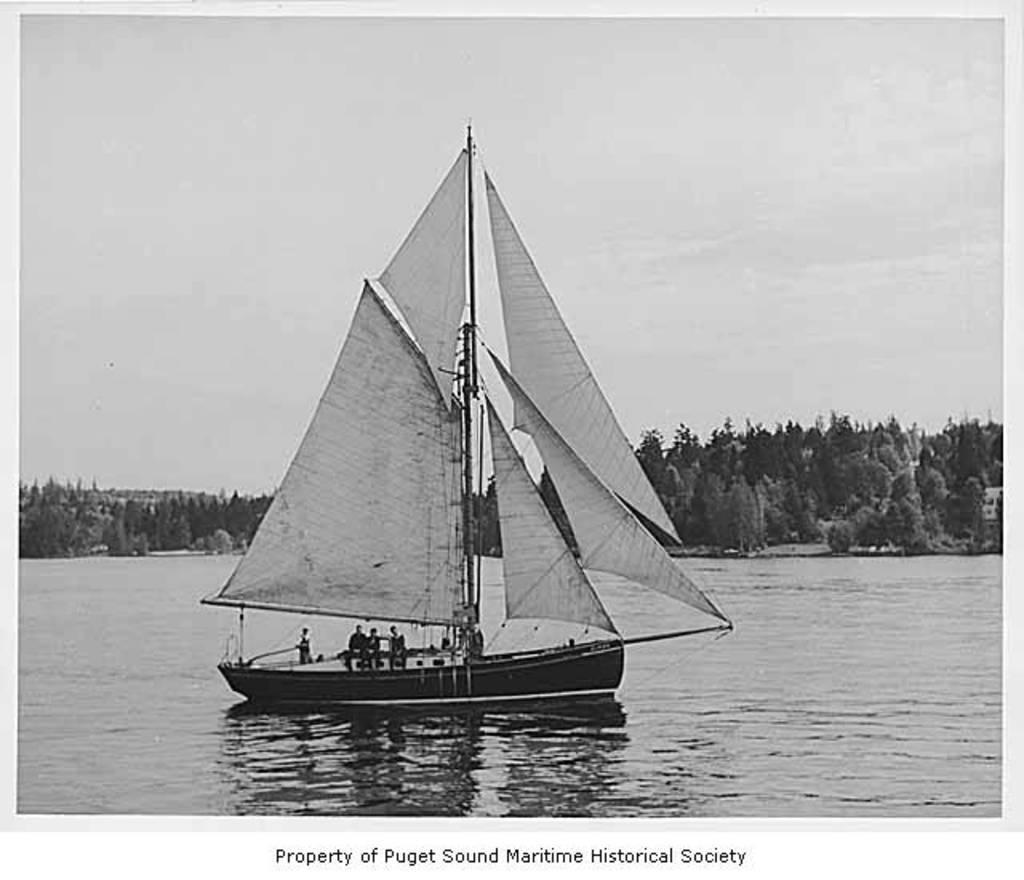How would you summarize this image in a sentence or two? This picture is in black and white. Here, we see the man is sailing the ship in the water. There are many trees in the background. At the bottom of the picture, we see some text written. This picture might be taken from the textbook. 